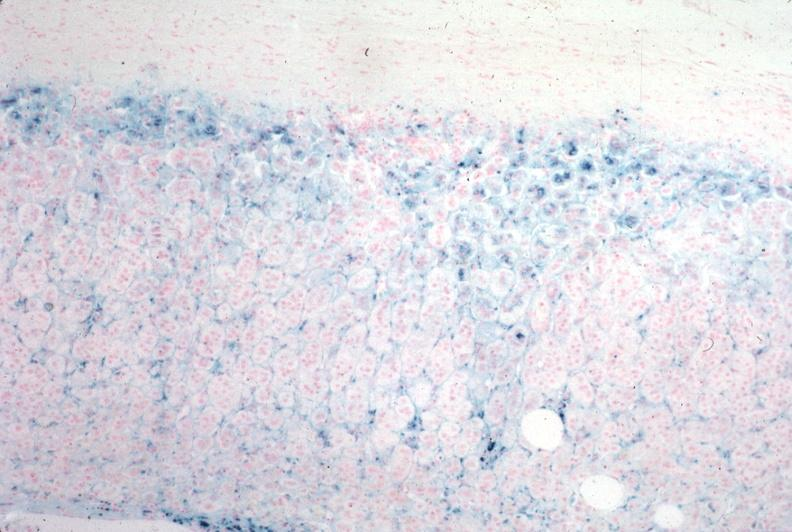does iron stain?
Answer the question using a single word or phrase. Yes 